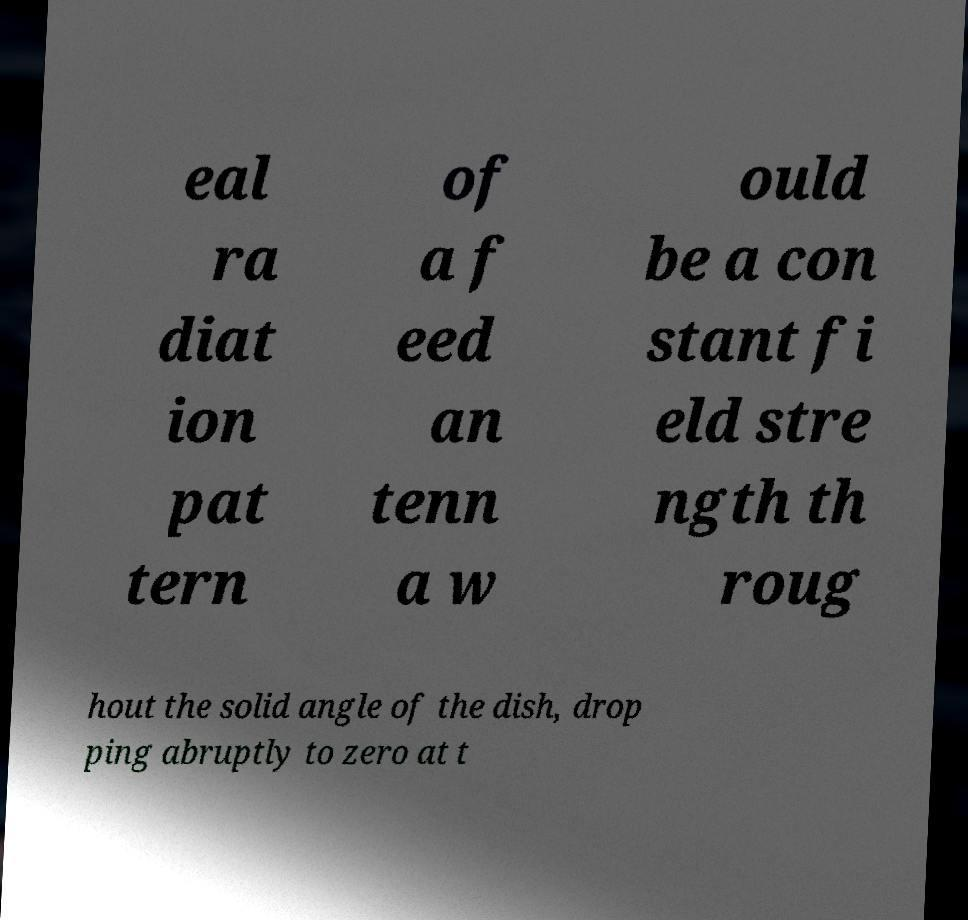For documentation purposes, I need the text within this image transcribed. Could you provide that? eal ra diat ion pat tern of a f eed an tenn a w ould be a con stant fi eld stre ngth th roug hout the solid angle of the dish, drop ping abruptly to zero at t 